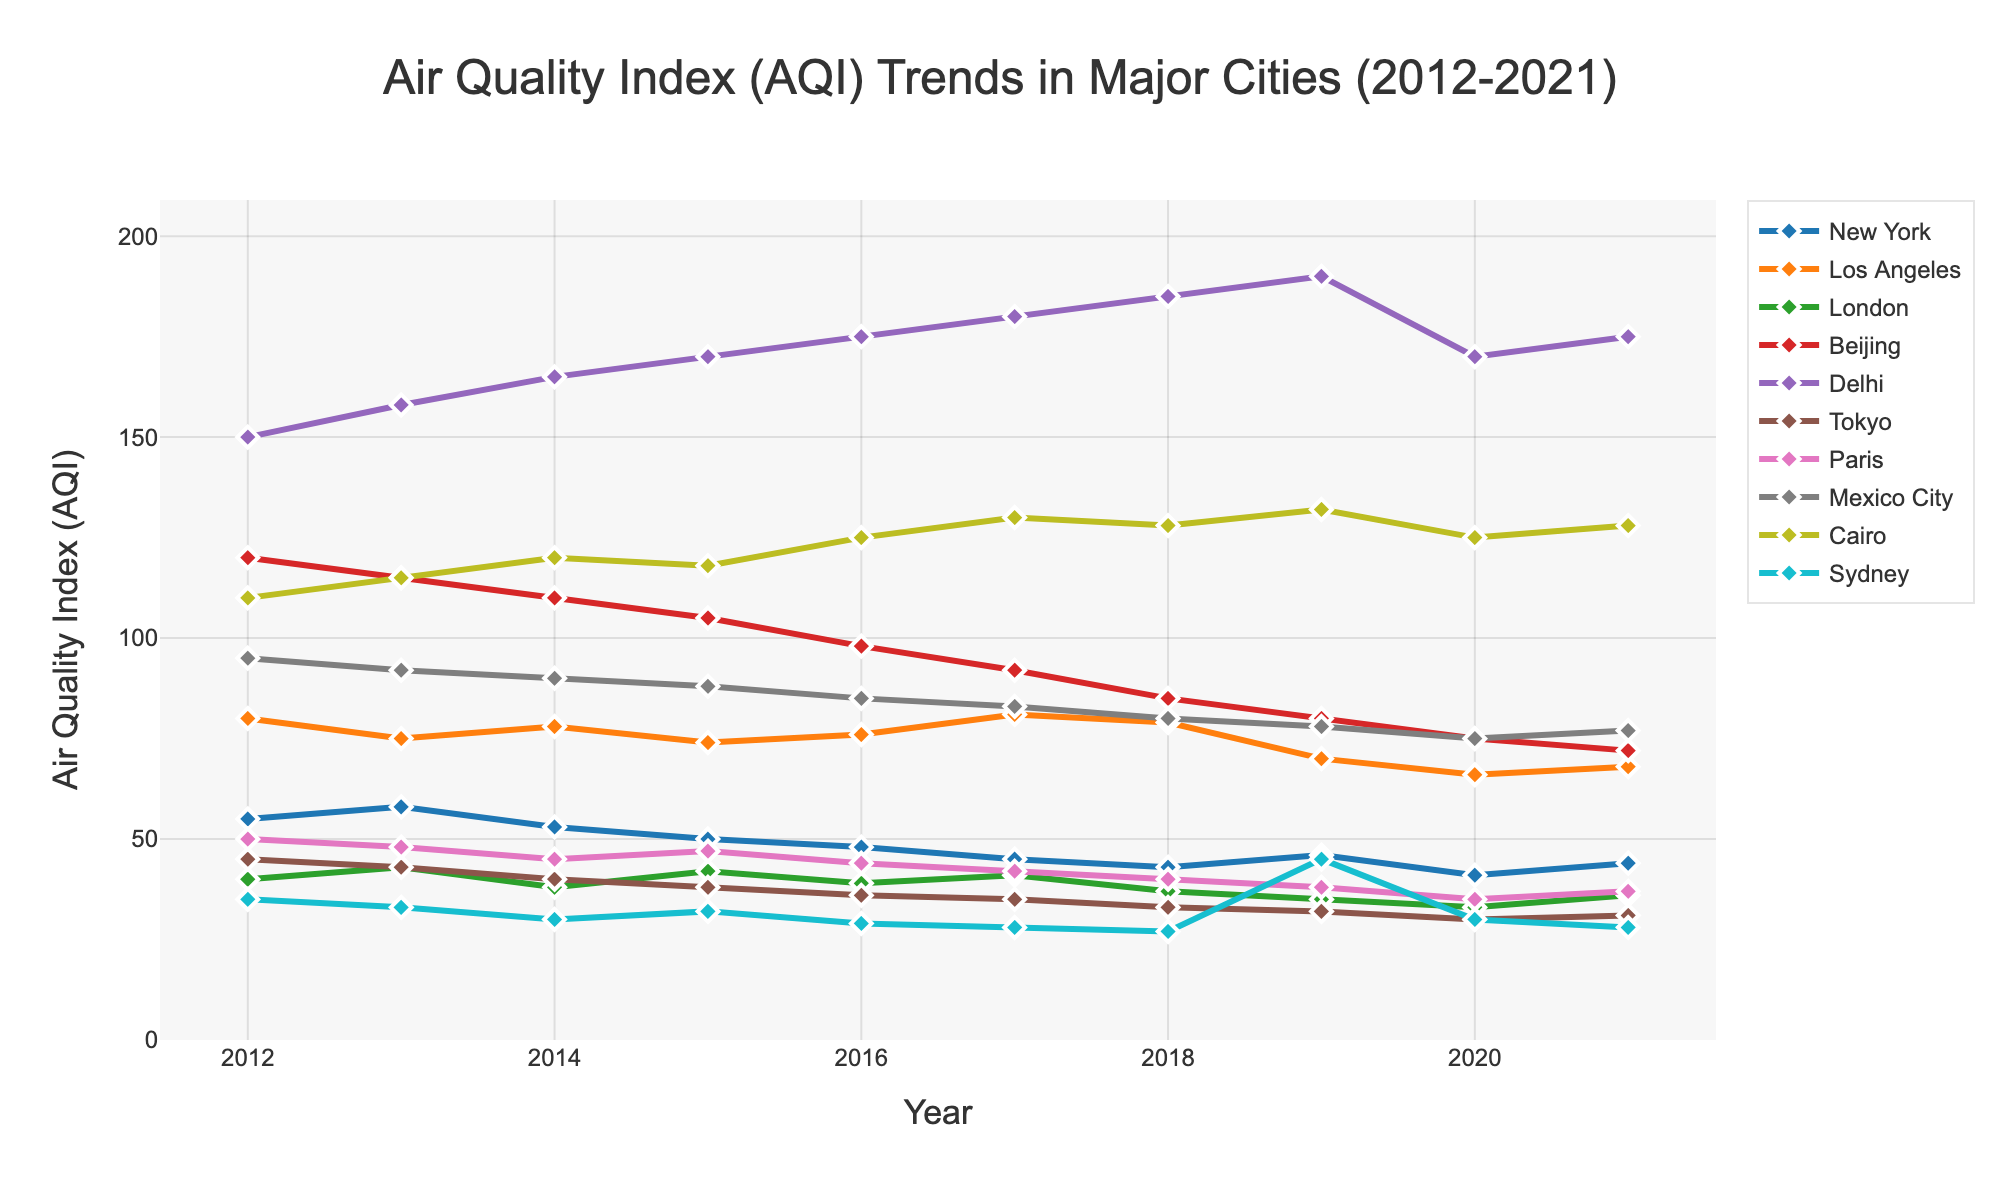what's the average AQI for Beijing over the decade? The AQI values for Beijing from 2012 to 2021 are 120, 115, 110, 105, 98, 92, 85, 80, 75, and 72. Summing these values: 120 + 115 + 110 + 105 + 98 + 92 + 85 + 80 + 75 + 72 = 952. There are 10 values, so the average AQI for Beijing is 952/10 = 95.2
Answer: 95.2 Which city had the highest AQI value in 2021? Looking at the plot for the year 2021, Delhi has the highest AQI value at 175, which is visually higher than any other city's AQI on the plot.
Answer: Delhi Did the AQI in New York increase or decrease from 2012 to 2021? The AQI in New York decreased from 55 in 2012 to 44 in 2021, which can be seen by comparing the heights of the lines and markers for those years.
Answer: Decrease Which city showed the largest drop in AQI from 2012 to 2021? Calculating the drop for each city: New York (55-44=11), Los Angeles (80-68=12), London (40-36=4), Beijing (120-72=48), Delhi (150-175=-25), Tokyo (45-31=14), Paris (50-37=13), Mexico City (95-77=18), Cairo (110-128=-18), Sydney (35-28=7). Therefore, Beijing showed the largest drop of 48.
Answer: Beijing Between London and Sydney, which city had a lower minimum AQI value over the decade? The AQI values for London are higher throughout the decade compared to Sydney. London's lowest value is 33, whereas Sydney's lowest value is 27.
Answer: Sydney How did the AQI trend of Cairo differ from that of New York over the decade? New York's AQI followed a generally decreasing trend over the decade. Cairo's AQI, however, generally trended upwards with some fluctuations.
Answer: Cairo increased, New York decreased What is the combined AQI for Paris and Tokyo in 2021? The AQI for Paris in 2021 is 37 and for Tokyo is 31. Adding these together: 37 + 31 = 68.
Answer: 68 Which city had the least variation in AQI values over the decade? Tokyo's AQI values exhibit the least variation, ranging narrowly from 45 to 30, which suggests very small fluctuations over the decade compared to other cities.
Answer: Tokyo 